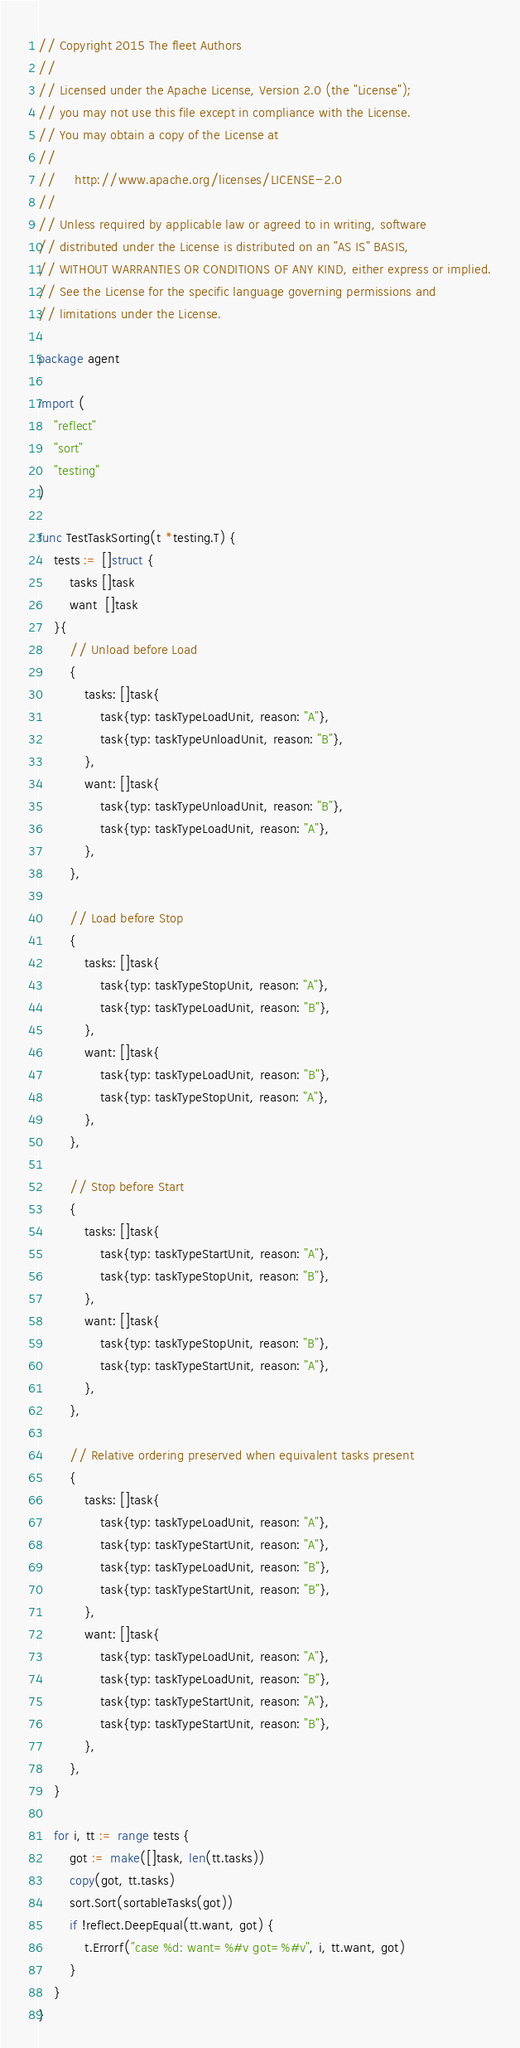Convert code to text. <code><loc_0><loc_0><loc_500><loc_500><_Go_>// Copyright 2015 The fleet Authors
//
// Licensed under the Apache License, Version 2.0 (the "License");
// you may not use this file except in compliance with the License.
// You may obtain a copy of the License at
//
//     http://www.apache.org/licenses/LICENSE-2.0
//
// Unless required by applicable law or agreed to in writing, software
// distributed under the License is distributed on an "AS IS" BASIS,
// WITHOUT WARRANTIES OR CONDITIONS OF ANY KIND, either express or implied.
// See the License for the specific language governing permissions and
// limitations under the License.

package agent

import (
	"reflect"
	"sort"
	"testing"
)

func TestTaskSorting(t *testing.T) {
	tests := []struct {
		tasks []task
		want  []task
	}{
		// Unload before Load
		{
			tasks: []task{
				task{typ: taskTypeLoadUnit, reason: "A"},
				task{typ: taskTypeUnloadUnit, reason: "B"},
			},
			want: []task{
				task{typ: taskTypeUnloadUnit, reason: "B"},
				task{typ: taskTypeLoadUnit, reason: "A"},
			},
		},

		// Load before Stop
		{
			tasks: []task{
				task{typ: taskTypeStopUnit, reason: "A"},
				task{typ: taskTypeLoadUnit, reason: "B"},
			},
			want: []task{
				task{typ: taskTypeLoadUnit, reason: "B"},
				task{typ: taskTypeStopUnit, reason: "A"},
			},
		},

		// Stop before Start
		{
			tasks: []task{
				task{typ: taskTypeStartUnit, reason: "A"},
				task{typ: taskTypeStopUnit, reason: "B"},
			},
			want: []task{
				task{typ: taskTypeStopUnit, reason: "B"},
				task{typ: taskTypeStartUnit, reason: "A"},
			},
		},

		// Relative ordering preserved when equivalent tasks present
		{
			tasks: []task{
				task{typ: taskTypeLoadUnit, reason: "A"},
				task{typ: taskTypeStartUnit, reason: "A"},
				task{typ: taskTypeLoadUnit, reason: "B"},
				task{typ: taskTypeStartUnit, reason: "B"},
			},
			want: []task{
				task{typ: taskTypeLoadUnit, reason: "A"},
				task{typ: taskTypeLoadUnit, reason: "B"},
				task{typ: taskTypeStartUnit, reason: "A"},
				task{typ: taskTypeStartUnit, reason: "B"},
			},
		},
	}

	for i, tt := range tests {
		got := make([]task, len(tt.tasks))
		copy(got, tt.tasks)
		sort.Sort(sortableTasks(got))
		if !reflect.DeepEqual(tt.want, got) {
			t.Errorf("case %d: want=%#v got=%#v", i, tt.want, got)
		}
	}
}
</code> 